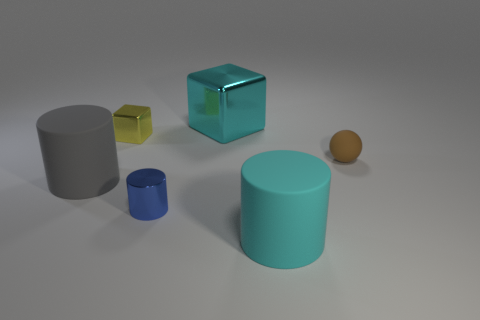Add 1 cyan shiny blocks. How many objects exist? 7 Subtract all spheres. How many objects are left? 5 Add 4 big cyan rubber cylinders. How many big cyan rubber cylinders exist? 5 Subtract 0 cyan balls. How many objects are left? 6 Subtract all blue shiny things. Subtract all cyan metallic blocks. How many objects are left? 4 Add 6 gray things. How many gray things are left? 7 